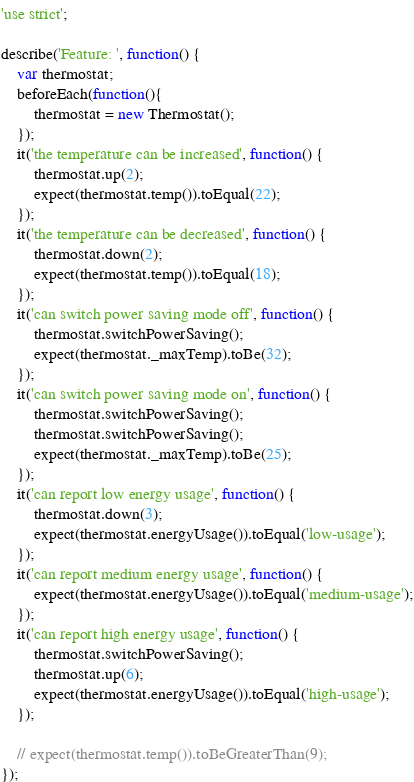Convert code to text. <code><loc_0><loc_0><loc_500><loc_500><_JavaScript_>'use strict';

describe('Feature: ', function() {
    var thermostat;
    beforeEach(function(){
        thermostat = new Thermostat();
    });
    it('the temperature can be increased', function() {
        thermostat.up(2);
        expect(thermostat.temp()).toEqual(22);
    });
    it('the temperature can be decreased', function() {
        thermostat.down(2);
        expect(thermostat.temp()).toEqual(18);
    });
    it('can switch power saving mode off', function() {
        thermostat.switchPowerSaving();
        expect(thermostat._maxTemp).toBe(32);
    });
    it('can switch power saving mode on', function() {
        thermostat.switchPowerSaving();
        thermostat.switchPowerSaving();
        expect(thermostat._maxTemp).toBe(25);
    });
    it('can report low energy usage', function() {
        thermostat.down(3);
        expect(thermostat.energyUsage()).toEqual('low-usage');
    });
    it('can report medium energy usage', function() {
        expect(thermostat.energyUsage()).toEqual('medium-usage');
    });
    it('can report high energy usage', function() {
        thermostat.switchPowerSaving();
        thermostat.up(6);
        expect(thermostat.energyUsage()).toEqual('high-usage');
    });

    // expect(thermostat.temp()).toBeGreaterThan(9);
});
</code> 